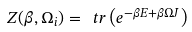<formula> <loc_0><loc_0><loc_500><loc_500>Z ( \beta , \Omega _ { i } ) = \ t r \left ( e ^ { - \beta E + \beta \Omega J } \right )</formula> 